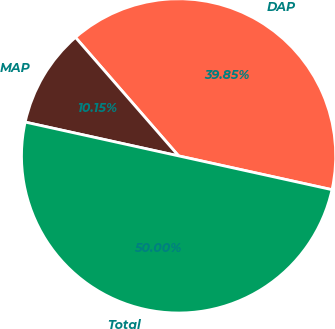Convert chart to OTSL. <chart><loc_0><loc_0><loc_500><loc_500><pie_chart><fcel>DAP<fcel>MAP<fcel>Total<nl><fcel>39.85%<fcel>10.15%<fcel>50.0%<nl></chart> 